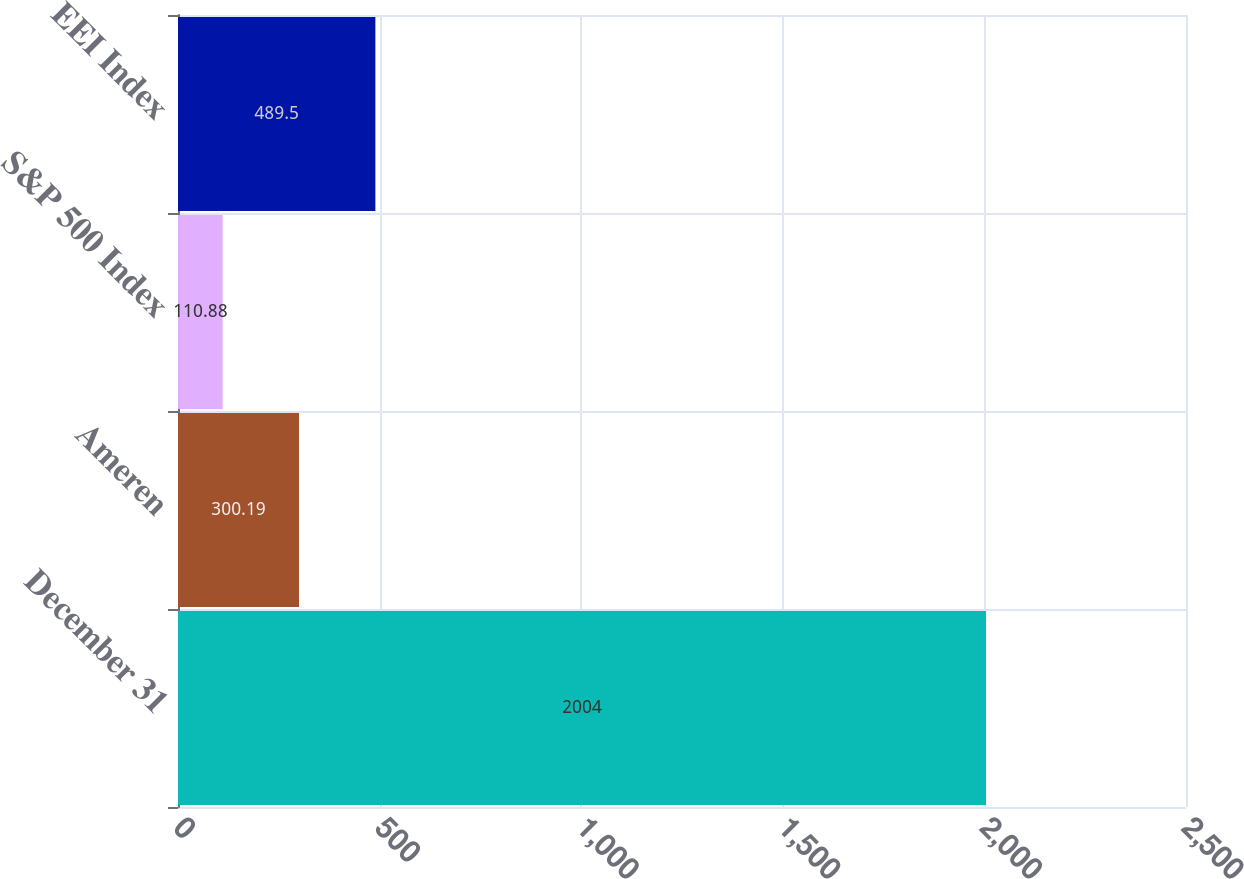<chart> <loc_0><loc_0><loc_500><loc_500><bar_chart><fcel>December 31<fcel>Ameren<fcel>S&P 500 Index<fcel>EEI Index<nl><fcel>2004<fcel>300.19<fcel>110.88<fcel>489.5<nl></chart> 